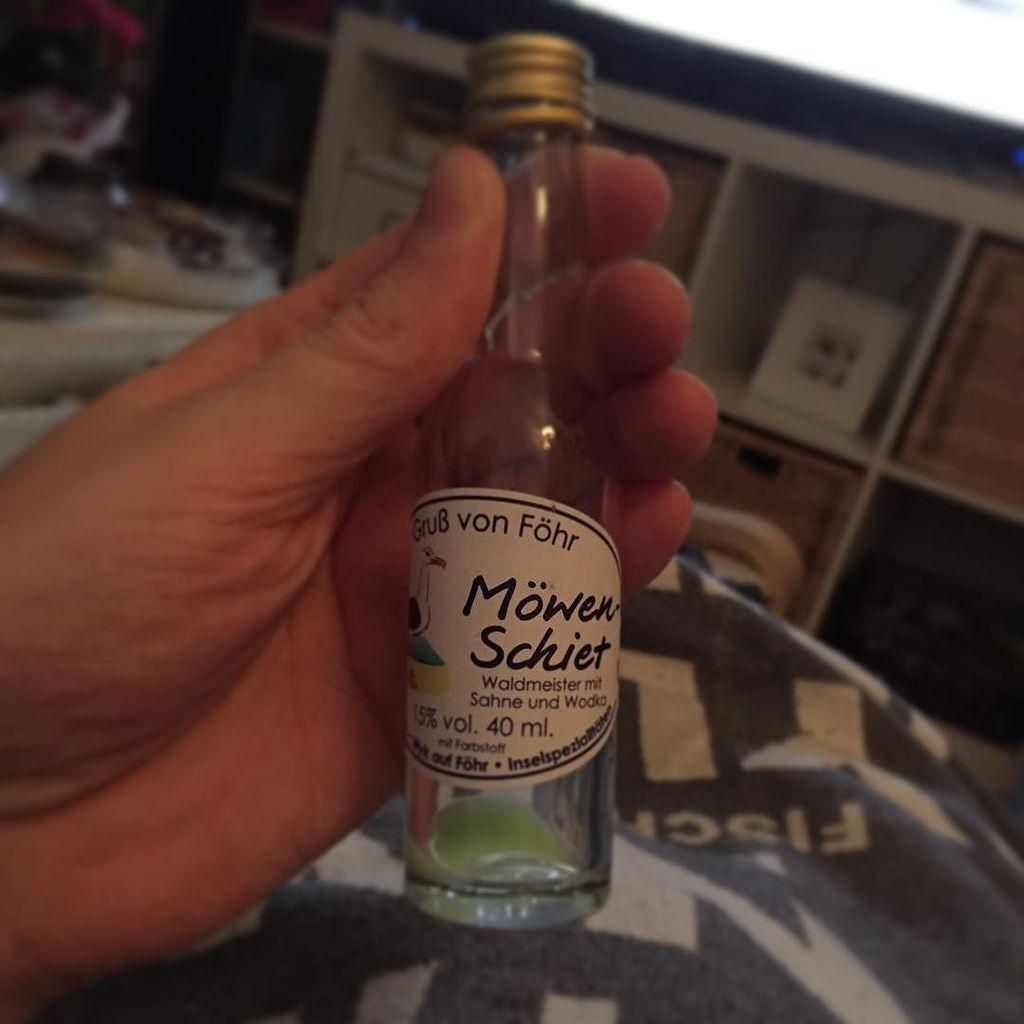<image>
Render a clear and concise summary of the photo. A person holds a small bottle of Mowen Schiet in their hand. 